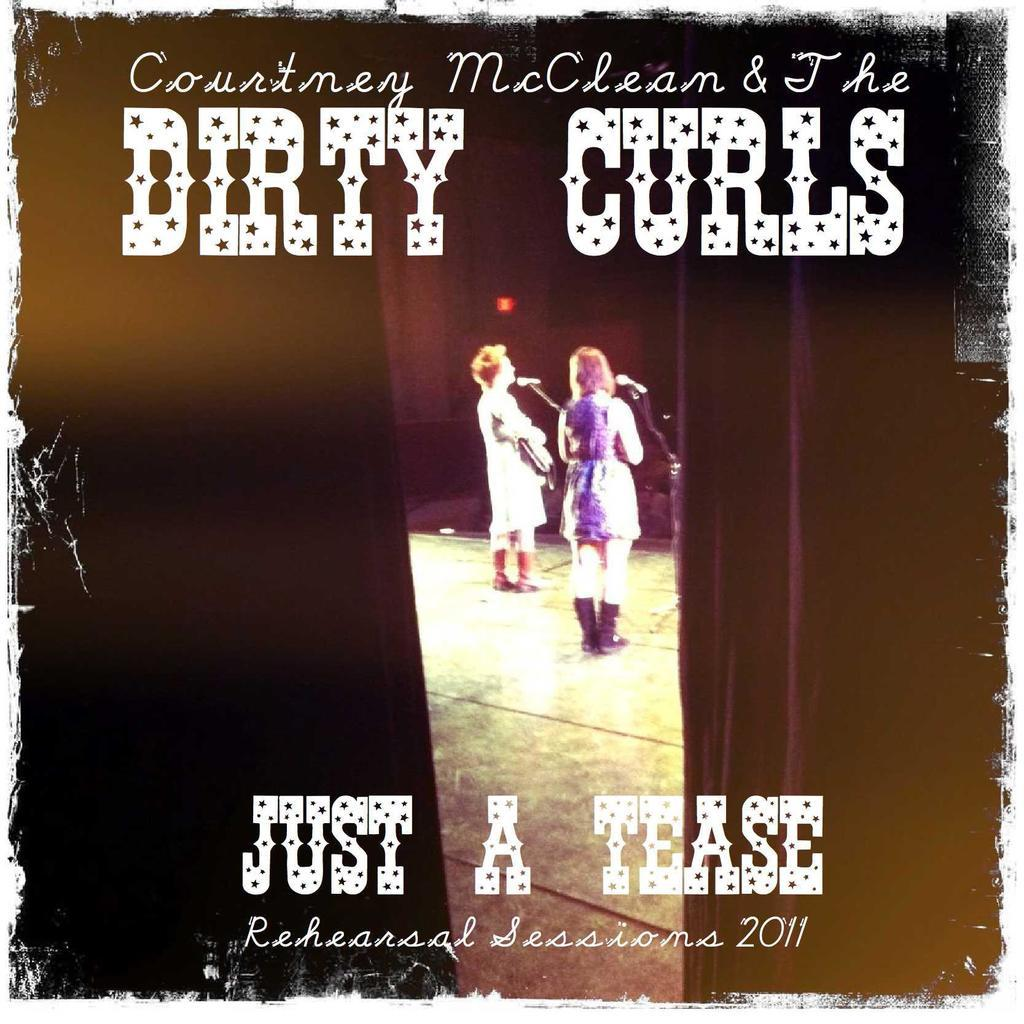<image>
Write a terse but informative summary of the picture. A picture of the Dirty Curls with Just a Tease on the bottom 